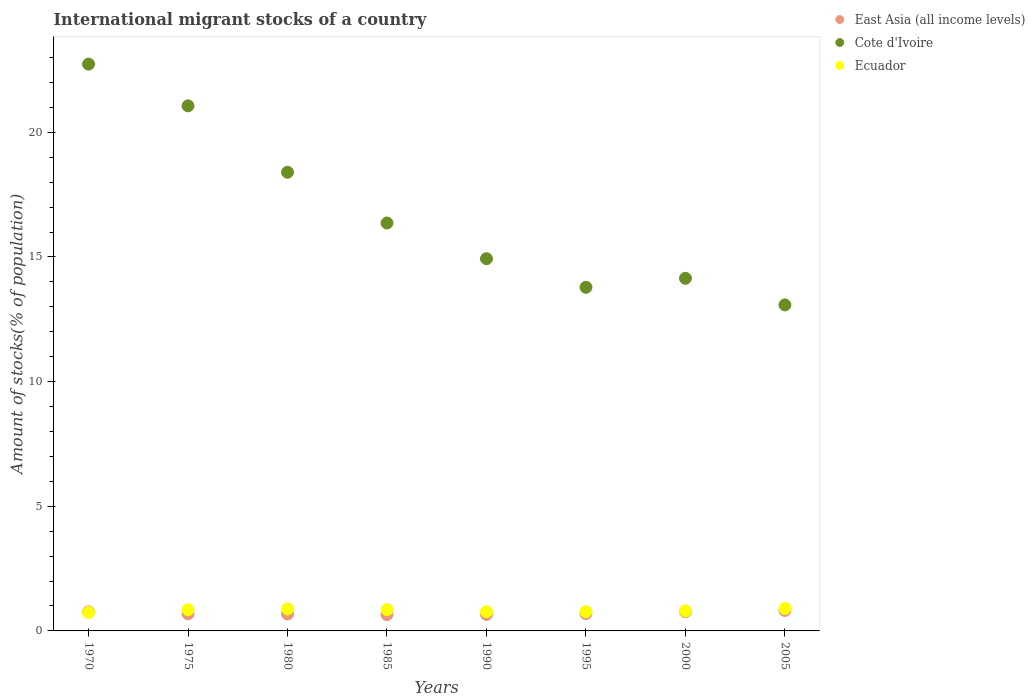How many different coloured dotlines are there?
Offer a terse response. 3. Is the number of dotlines equal to the number of legend labels?
Give a very brief answer. Yes. What is the amount of stocks in in East Asia (all income levels) in 1980?
Provide a short and direct response. 0.68. Across all years, what is the maximum amount of stocks in in Ecuador?
Give a very brief answer. 0.9. Across all years, what is the minimum amount of stocks in in Cote d'Ivoire?
Offer a very short reply. 13.08. In which year was the amount of stocks in in Ecuador minimum?
Provide a succinct answer. 1970. What is the total amount of stocks in in Ecuador in the graph?
Your response must be concise. 6.57. What is the difference between the amount of stocks in in Ecuador in 1970 and that in 1980?
Your answer should be very brief. -0.14. What is the difference between the amount of stocks in in Cote d'Ivoire in 2005 and the amount of stocks in in East Asia (all income levels) in 1980?
Provide a short and direct response. 12.4. What is the average amount of stocks in in East Asia (all income levels) per year?
Your response must be concise. 0.72. In the year 1975, what is the difference between the amount of stocks in in Cote d'Ivoire and amount of stocks in in Ecuador?
Provide a short and direct response. 20.21. What is the ratio of the amount of stocks in in Cote d'Ivoire in 1975 to that in 2000?
Provide a succinct answer. 1.49. Is the amount of stocks in in Cote d'Ivoire in 1985 less than that in 2005?
Your response must be concise. No. Is the difference between the amount of stocks in in Cote d'Ivoire in 1990 and 1995 greater than the difference between the amount of stocks in in Ecuador in 1990 and 1995?
Your answer should be compact. Yes. What is the difference between the highest and the second highest amount of stocks in in Cote d'Ivoire?
Provide a short and direct response. 1.67. What is the difference between the highest and the lowest amount of stocks in in Cote d'Ivoire?
Offer a terse response. 9.66. In how many years, is the amount of stocks in in Cote d'Ivoire greater than the average amount of stocks in in Cote d'Ivoire taken over all years?
Ensure brevity in your answer.  3. Is it the case that in every year, the sum of the amount of stocks in in East Asia (all income levels) and amount of stocks in in Cote d'Ivoire  is greater than the amount of stocks in in Ecuador?
Provide a short and direct response. Yes. Does the amount of stocks in in Cote d'Ivoire monotonically increase over the years?
Give a very brief answer. No. Is the amount of stocks in in Cote d'Ivoire strictly greater than the amount of stocks in in Ecuador over the years?
Your answer should be very brief. Yes. Are the values on the major ticks of Y-axis written in scientific E-notation?
Your answer should be compact. No. Does the graph contain any zero values?
Your answer should be very brief. No. How are the legend labels stacked?
Offer a very short reply. Vertical. What is the title of the graph?
Provide a short and direct response. International migrant stocks of a country. Does "Switzerland" appear as one of the legend labels in the graph?
Make the answer very short. No. What is the label or title of the X-axis?
Ensure brevity in your answer.  Years. What is the label or title of the Y-axis?
Your answer should be compact. Amount of stocks(% of population). What is the Amount of stocks(% of population) of East Asia (all income levels) in 1970?
Provide a short and direct response. 0.76. What is the Amount of stocks(% of population) of Cote d'Ivoire in 1970?
Offer a very short reply. 22.74. What is the Amount of stocks(% of population) of Ecuador in 1970?
Your answer should be very brief. 0.74. What is the Amount of stocks(% of population) in East Asia (all income levels) in 1975?
Give a very brief answer. 0.69. What is the Amount of stocks(% of population) in Cote d'Ivoire in 1975?
Ensure brevity in your answer.  21.06. What is the Amount of stocks(% of population) of Ecuador in 1975?
Ensure brevity in your answer.  0.85. What is the Amount of stocks(% of population) in East Asia (all income levels) in 1980?
Keep it short and to the point. 0.68. What is the Amount of stocks(% of population) in Cote d'Ivoire in 1980?
Your answer should be compact. 18.4. What is the Amount of stocks(% of population) in Ecuador in 1980?
Your answer should be compact. 0.88. What is the Amount of stocks(% of population) in East Asia (all income levels) in 1985?
Give a very brief answer. 0.66. What is the Amount of stocks(% of population) in Cote d'Ivoire in 1985?
Your response must be concise. 16.36. What is the Amount of stocks(% of population) of Ecuador in 1985?
Provide a short and direct response. 0.85. What is the Amount of stocks(% of population) in East Asia (all income levels) in 1990?
Keep it short and to the point. 0.66. What is the Amount of stocks(% of population) in Cote d'Ivoire in 1990?
Provide a short and direct response. 14.93. What is the Amount of stocks(% of population) in Ecuador in 1990?
Offer a very short reply. 0.77. What is the Amount of stocks(% of population) in East Asia (all income levels) in 1995?
Offer a terse response. 0.7. What is the Amount of stocks(% of population) in Cote d'Ivoire in 1995?
Keep it short and to the point. 13.78. What is the Amount of stocks(% of population) in Ecuador in 1995?
Keep it short and to the point. 0.77. What is the Amount of stocks(% of population) in East Asia (all income levels) in 2000?
Give a very brief answer. 0.77. What is the Amount of stocks(% of population) of Cote d'Ivoire in 2000?
Provide a succinct answer. 14.14. What is the Amount of stocks(% of population) in Ecuador in 2000?
Provide a succinct answer. 0.8. What is the Amount of stocks(% of population) in East Asia (all income levels) in 2005?
Your response must be concise. 0.82. What is the Amount of stocks(% of population) in Cote d'Ivoire in 2005?
Offer a very short reply. 13.08. What is the Amount of stocks(% of population) in Ecuador in 2005?
Give a very brief answer. 0.9. Across all years, what is the maximum Amount of stocks(% of population) of East Asia (all income levels)?
Make the answer very short. 0.82. Across all years, what is the maximum Amount of stocks(% of population) in Cote d'Ivoire?
Ensure brevity in your answer.  22.74. Across all years, what is the maximum Amount of stocks(% of population) of Ecuador?
Provide a short and direct response. 0.9. Across all years, what is the minimum Amount of stocks(% of population) in East Asia (all income levels)?
Make the answer very short. 0.66. Across all years, what is the minimum Amount of stocks(% of population) of Cote d'Ivoire?
Your response must be concise. 13.08. Across all years, what is the minimum Amount of stocks(% of population) of Ecuador?
Offer a very short reply. 0.74. What is the total Amount of stocks(% of population) of East Asia (all income levels) in the graph?
Make the answer very short. 5.73. What is the total Amount of stocks(% of population) of Cote d'Ivoire in the graph?
Keep it short and to the point. 134.49. What is the total Amount of stocks(% of population) of Ecuador in the graph?
Your response must be concise. 6.57. What is the difference between the Amount of stocks(% of population) in East Asia (all income levels) in 1970 and that in 1975?
Provide a succinct answer. 0.08. What is the difference between the Amount of stocks(% of population) of Cote d'Ivoire in 1970 and that in 1975?
Give a very brief answer. 1.67. What is the difference between the Amount of stocks(% of population) in Ecuador in 1970 and that in 1975?
Give a very brief answer. -0.11. What is the difference between the Amount of stocks(% of population) of East Asia (all income levels) in 1970 and that in 1980?
Give a very brief answer. 0.09. What is the difference between the Amount of stocks(% of population) of Cote d'Ivoire in 1970 and that in 1980?
Provide a short and direct response. 4.34. What is the difference between the Amount of stocks(% of population) of Ecuador in 1970 and that in 1980?
Ensure brevity in your answer.  -0.14. What is the difference between the Amount of stocks(% of population) of East Asia (all income levels) in 1970 and that in 1985?
Provide a succinct answer. 0.11. What is the difference between the Amount of stocks(% of population) in Cote d'Ivoire in 1970 and that in 1985?
Provide a succinct answer. 6.38. What is the difference between the Amount of stocks(% of population) of Ecuador in 1970 and that in 1985?
Keep it short and to the point. -0.12. What is the difference between the Amount of stocks(% of population) in East Asia (all income levels) in 1970 and that in 1990?
Make the answer very short. 0.1. What is the difference between the Amount of stocks(% of population) in Cote d'Ivoire in 1970 and that in 1990?
Ensure brevity in your answer.  7.81. What is the difference between the Amount of stocks(% of population) of Ecuador in 1970 and that in 1990?
Provide a succinct answer. -0.03. What is the difference between the Amount of stocks(% of population) in East Asia (all income levels) in 1970 and that in 1995?
Make the answer very short. 0.07. What is the difference between the Amount of stocks(% of population) in Cote d'Ivoire in 1970 and that in 1995?
Give a very brief answer. 8.95. What is the difference between the Amount of stocks(% of population) of Ecuador in 1970 and that in 1995?
Your answer should be compact. -0.03. What is the difference between the Amount of stocks(% of population) in East Asia (all income levels) in 1970 and that in 2000?
Offer a terse response. -0. What is the difference between the Amount of stocks(% of population) in Cote d'Ivoire in 1970 and that in 2000?
Give a very brief answer. 8.59. What is the difference between the Amount of stocks(% of population) of Ecuador in 1970 and that in 2000?
Keep it short and to the point. -0.07. What is the difference between the Amount of stocks(% of population) in East Asia (all income levels) in 1970 and that in 2005?
Make the answer very short. -0.06. What is the difference between the Amount of stocks(% of population) of Cote d'Ivoire in 1970 and that in 2005?
Give a very brief answer. 9.66. What is the difference between the Amount of stocks(% of population) of Ecuador in 1970 and that in 2005?
Ensure brevity in your answer.  -0.16. What is the difference between the Amount of stocks(% of population) in East Asia (all income levels) in 1975 and that in 1980?
Offer a very short reply. 0.01. What is the difference between the Amount of stocks(% of population) of Cote d'Ivoire in 1975 and that in 1980?
Offer a very short reply. 2.66. What is the difference between the Amount of stocks(% of population) of Ecuador in 1975 and that in 1980?
Give a very brief answer. -0.03. What is the difference between the Amount of stocks(% of population) in East Asia (all income levels) in 1975 and that in 1985?
Provide a short and direct response. 0.03. What is the difference between the Amount of stocks(% of population) in Cote d'Ivoire in 1975 and that in 1985?
Keep it short and to the point. 4.7. What is the difference between the Amount of stocks(% of population) in Ecuador in 1975 and that in 1985?
Ensure brevity in your answer.  -0. What is the difference between the Amount of stocks(% of population) in East Asia (all income levels) in 1975 and that in 1990?
Your response must be concise. 0.02. What is the difference between the Amount of stocks(% of population) in Cote d'Ivoire in 1975 and that in 1990?
Your answer should be very brief. 6.13. What is the difference between the Amount of stocks(% of population) of Ecuador in 1975 and that in 1990?
Keep it short and to the point. 0.08. What is the difference between the Amount of stocks(% of population) in East Asia (all income levels) in 1975 and that in 1995?
Ensure brevity in your answer.  -0.01. What is the difference between the Amount of stocks(% of population) in Cote d'Ivoire in 1975 and that in 1995?
Your answer should be very brief. 7.28. What is the difference between the Amount of stocks(% of population) of Ecuador in 1975 and that in 1995?
Make the answer very short. 0.08. What is the difference between the Amount of stocks(% of population) in East Asia (all income levels) in 1975 and that in 2000?
Your answer should be very brief. -0.08. What is the difference between the Amount of stocks(% of population) in Cote d'Ivoire in 1975 and that in 2000?
Your response must be concise. 6.92. What is the difference between the Amount of stocks(% of population) in Ecuador in 1975 and that in 2000?
Give a very brief answer. 0.05. What is the difference between the Amount of stocks(% of population) in East Asia (all income levels) in 1975 and that in 2005?
Make the answer very short. -0.14. What is the difference between the Amount of stocks(% of population) in Cote d'Ivoire in 1975 and that in 2005?
Provide a succinct answer. 7.98. What is the difference between the Amount of stocks(% of population) in Ecuador in 1975 and that in 2005?
Keep it short and to the point. -0.05. What is the difference between the Amount of stocks(% of population) in East Asia (all income levels) in 1980 and that in 1985?
Make the answer very short. 0.02. What is the difference between the Amount of stocks(% of population) of Cote d'Ivoire in 1980 and that in 1985?
Your answer should be compact. 2.04. What is the difference between the Amount of stocks(% of population) of Ecuador in 1980 and that in 1985?
Provide a succinct answer. 0.03. What is the difference between the Amount of stocks(% of population) of East Asia (all income levels) in 1980 and that in 1990?
Offer a very short reply. 0.02. What is the difference between the Amount of stocks(% of population) of Cote d'Ivoire in 1980 and that in 1990?
Your answer should be very brief. 3.47. What is the difference between the Amount of stocks(% of population) of Ecuador in 1980 and that in 1990?
Provide a succinct answer. 0.11. What is the difference between the Amount of stocks(% of population) of East Asia (all income levels) in 1980 and that in 1995?
Give a very brief answer. -0.02. What is the difference between the Amount of stocks(% of population) of Cote d'Ivoire in 1980 and that in 1995?
Provide a short and direct response. 4.62. What is the difference between the Amount of stocks(% of population) of Ecuador in 1980 and that in 1995?
Provide a succinct answer. 0.11. What is the difference between the Amount of stocks(% of population) of East Asia (all income levels) in 1980 and that in 2000?
Make the answer very short. -0.09. What is the difference between the Amount of stocks(% of population) of Cote d'Ivoire in 1980 and that in 2000?
Offer a very short reply. 4.25. What is the difference between the Amount of stocks(% of population) in Ecuador in 1980 and that in 2000?
Make the answer very short. 0.08. What is the difference between the Amount of stocks(% of population) in East Asia (all income levels) in 1980 and that in 2005?
Provide a succinct answer. -0.14. What is the difference between the Amount of stocks(% of population) of Cote d'Ivoire in 1980 and that in 2005?
Keep it short and to the point. 5.32. What is the difference between the Amount of stocks(% of population) in Ecuador in 1980 and that in 2005?
Keep it short and to the point. -0.02. What is the difference between the Amount of stocks(% of population) in East Asia (all income levels) in 1985 and that in 1990?
Your response must be concise. -0.01. What is the difference between the Amount of stocks(% of population) of Cote d'Ivoire in 1985 and that in 1990?
Give a very brief answer. 1.43. What is the difference between the Amount of stocks(% of population) of Ecuador in 1985 and that in 1990?
Provide a short and direct response. 0.08. What is the difference between the Amount of stocks(% of population) in East Asia (all income levels) in 1985 and that in 1995?
Your response must be concise. -0.04. What is the difference between the Amount of stocks(% of population) of Cote d'Ivoire in 1985 and that in 1995?
Your answer should be compact. 2.58. What is the difference between the Amount of stocks(% of population) in Ecuador in 1985 and that in 1995?
Your answer should be very brief. 0.08. What is the difference between the Amount of stocks(% of population) in East Asia (all income levels) in 1985 and that in 2000?
Make the answer very short. -0.11. What is the difference between the Amount of stocks(% of population) in Cote d'Ivoire in 1985 and that in 2000?
Provide a succinct answer. 2.22. What is the difference between the Amount of stocks(% of population) of Ecuador in 1985 and that in 2000?
Your answer should be very brief. 0.05. What is the difference between the Amount of stocks(% of population) in East Asia (all income levels) in 1985 and that in 2005?
Ensure brevity in your answer.  -0.17. What is the difference between the Amount of stocks(% of population) in Cote d'Ivoire in 1985 and that in 2005?
Your answer should be compact. 3.28. What is the difference between the Amount of stocks(% of population) in Ecuador in 1985 and that in 2005?
Provide a succinct answer. -0.05. What is the difference between the Amount of stocks(% of population) of East Asia (all income levels) in 1990 and that in 1995?
Provide a succinct answer. -0.04. What is the difference between the Amount of stocks(% of population) of Cote d'Ivoire in 1990 and that in 1995?
Your answer should be very brief. 1.15. What is the difference between the Amount of stocks(% of population) in Ecuador in 1990 and that in 1995?
Your answer should be compact. -0. What is the difference between the Amount of stocks(% of population) of East Asia (all income levels) in 1990 and that in 2000?
Keep it short and to the point. -0.11. What is the difference between the Amount of stocks(% of population) of Cote d'Ivoire in 1990 and that in 2000?
Your response must be concise. 0.79. What is the difference between the Amount of stocks(% of population) of Ecuador in 1990 and that in 2000?
Your answer should be compact. -0.03. What is the difference between the Amount of stocks(% of population) in East Asia (all income levels) in 1990 and that in 2005?
Keep it short and to the point. -0.16. What is the difference between the Amount of stocks(% of population) in Cote d'Ivoire in 1990 and that in 2005?
Offer a very short reply. 1.85. What is the difference between the Amount of stocks(% of population) of Ecuador in 1990 and that in 2005?
Keep it short and to the point. -0.13. What is the difference between the Amount of stocks(% of population) in East Asia (all income levels) in 1995 and that in 2000?
Ensure brevity in your answer.  -0.07. What is the difference between the Amount of stocks(% of population) in Cote d'Ivoire in 1995 and that in 2000?
Provide a short and direct response. -0.36. What is the difference between the Amount of stocks(% of population) of Ecuador in 1995 and that in 2000?
Keep it short and to the point. -0.03. What is the difference between the Amount of stocks(% of population) of East Asia (all income levels) in 1995 and that in 2005?
Offer a terse response. -0.13. What is the difference between the Amount of stocks(% of population) of Cote d'Ivoire in 1995 and that in 2005?
Your answer should be compact. 0.7. What is the difference between the Amount of stocks(% of population) in Ecuador in 1995 and that in 2005?
Make the answer very short. -0.13. What is the difference between the Amount of stocks(% of population) of East Asia (all income levels) in 2000 and that in 2005?
Ensure brevity in your answer.  -0.05. What is the difference between the Amount of stocks(% of population) of Cote d'Ivoire in 2000 and that in 2005?
Your response must be concise. 1.07. What is the difference between the Amount of stocks(% of population) in Ecuador in 2000 and that in 2005?
Your answer should be very brief. -0.1. What is the difference between the Amount of stocks(% of population) in East Asia (all income levels) in 1970 and the Amount of stocks(% of population) in Cote d'Ivoire in 1975?
Offer a very short reply. -20.3. What is the difference between the Amount of stocks(% of population) of East Asia (all income levels) in 1970 and the Amount of stocks(% of population) of Ecuador in 1975?
Give a very brief answer. -0.08. What is the difference between the Amount of stocks(% of population) of Cote d'Ivoire in 1970 and the Amount of stocks(% of population) of Ecuador in 1975?
Your answer should be compact. 21.89. What is the difference between the Amount of stocks(% of population) of East Asia (all income levels) in 1970 and the Amount of stocks(% of population) of Cote d'Ivoire in 1980?
Keep it short and to the point. -17.63. What is the difference between the Amount of stocks(% of population) in East Asia (all income levels) in 1970 and the Amount of stocks(% of population) in Ecuador in 1980?
Provide a short and direct response. -0.12. What is the difference between the Amount of stocks(% of population) of Cote d'Ivoire in 1970 and the Amount of stocks(% of population) of Ecuador in 1980?
Keep it short and to the point. 21.85. What is the difference between the Amount of stocks(% of population) of East Asia (all income levels) in 1970 and the Amount of stocks(% of population) of Cote d'Ivoire in 1985?
Offer a very short reply. -15.6. What is the difference between the Amount of stocks(% of population) in East Asia (all income levels) in 1970 and the Amount of stocks(% of population) in Ecuador in 1985?
Your answer should be compact. -0.09. What is the difference between the Amount of stocks(% of population) in Cote d'Ivoire in 1970 and the Amount of stocks(% of population) in Ecuador in 1985?
Your answer should be compact. 21.88. What is the difference between the Amount of stocks(% of population) of East Asia (all income levels) in 1970 and the Amount of stocks(% of population) of Cote d'Ivoire in 1990?
Your answer should be very brief. -14.17. What is the difference between the Amount of stocks(% of population) in East Asia (all income levels) in 1970 and the Amount of stocks(% of population) in Ecuador in 1990?
Your answer should be very brief. -0.01. What is the difference between the Amount of stocks(% of population) in Cote d'Ivoire in 1970 and the Amount of stocks(% of population) in Ecuador in 1990?
Make the answer very short. 21.97. What is the difference between the Amount of stocks(% of population) of East Asia (all income levels) in 1970 and the Amount of stocks(% of population) of Cote d'Ivoire in 1995?
Ensure brevity in your answer.  -13.02. What is the difference between the Amount of stocks(% of population) in East Asia (all income levels) in 1970 and the Amount of stocks(% of population) in Ecuador in 1995?
Provide a short and direct response. -0.01. What is the difference between the Amount of stocks(% of population) in Cote d'Ivoire in 1970 and the Amount of stocks(% of population) in Ecuador in 1995?
Offer a very short reply. 21.96. What is the difference between the Amount of stocks(% of population) in East Asia (all income levels) in 1970 and the Amount of stocks(% of population) in Cote d'Ivoire in 2000?
Ensure brevity in your answer.  -13.38. What is the difference between the Amount of stocks(% of population) of East Asia (all income levels) in 1970 and the Amount of stocks(% of population) of Ecuador in 2000?
Your answer should be compact. -0.04. What is the difference between the Amount of stocks(% of population) of Cote d'Ivoire in 1970 and the Amount of stocks(% of population) of Ecuador in 2000?
Make the answer very short. 21.93. What is the difference between the Amount of stocks(% of population) in East Asia (all income levels) in 1970 and the Amount of stocks(% of population) in Cote d'Ivoire in 2005?
Provide a succinct answer. -12.31. What is the difference between the Amount of stocks(% of population) of East Asia (all income levels) in 1970 and the Amount of stocks(% of population) of Ecuador in 2005?
Your answer should be very brief. -0.14. What is the difference between the Amount of stocks(% of population) in Cote d'Ivoire in 1970 and the Amount of stocks(% of population) in Ecuador in 2005?
Your response must be concise. 21.84. What is the difference between the Amount of stocks(% of population) in East Asia (all income levels) in 1975 and the Amount of stocks(% of population) in Cote d'Ivoire in 1980?
Your answer should be very brief. -17.71. What is the difference between the Amount of stocks(% of population) of East Asia (all income levels) in 1975 and the Amount of stocks(% of population) of Ecuador in 1980?
Provide a succinct answer. -0.2. What is the difference between the Amount of stocks(% of population) of Cote d'Ivoire in 1975 and the Amount of stocks(% of population) of Ecuador in 1980?
Give a very brief answer. 20.18. What is the difference between the Amount of stocks(% of population) in East Asia (all income levels) in 1975 and the Amount of stocks(% of population) in Cote d'Ivoire in 1985?
Your answer should be compact. -15.68. What is the difference between the Amount of stocks(% of population) of East Asia (all income levels) in 1975 and the Amount of stocks(% of population) of Ecuador in 1985?
Provide a short and direct response. -0.17. What is the difference between the Amount of stocks(% of population) of Cote d'Ivoire in 1975 and the Amount of stocks(% of population) of Ecuador in 1985?
Ensure brevity in your answer.  20.21. What is the difference between the Amount of stocks(% of population) in East Asia (all income levels) in 1975 and the Amount of stocks(% of population) in Cote d'Ivoire in 1990?
Give a very brief answer. -14.25. What is the difference between the Amount of stocks(% of population) in East Asia (all income levels) in 1975 and the Amount of stocks(% of population) in Ecuador in 1990?
Offer a very short reply. -0.08. What is the difference between the Amount of stocks(% of population) of Cote d'Ivoire in 1975 and the Amount of stocks(% of population) of Ecuador in 1990?
Provide a short and direct response. 20.29. What is the difference between the Amount of stocks(% of population) in East Asia (all income levels) in 1975 and the Amount of stocks(% of population) in Cote d'Ivoire in 1995?
Give a very brief answer. -13.1. What is the difference between the Amount of stocks(% of population) in East Asia (all income levels) in 1975 and the Amount of stocks(% of population) in Ecuador in 1995?
Offer a very short reply. -0.09. What is the difference between the Amount of stocks(% of population) in Cote d'Ivoire in 1975 and the Amount of stocks(% of population) in Ecuador in 1995?
Provide a short and direct response. 20.29. What is the difference between the Amount of stocks(% of population) in East Asia (all income levels) in 1975 and the Amount of stocks(% of population) in Cote d'Ivoire in 2000?
Your answer should be compact. -13.46. What is the difference between the Amount of stocks(% of population) in East Asia (all income levels) in 1975 and the Amount of stocks(% of population) in Ecuador in 2000?
Your response must be concise. -0.12. What is the difference between the Amount of stocks(% of population) of Cote d'Ivoire in 1975 and the Amount of stocks(% of population) of Ecuador in 2000?
Your answer should be compact. 20.26. What is the difference between the Amount of stocks(% of population) in East Asia (all income levels) in 1975 and the Amount of stocks(% of population) in Cote d'Ivoire in 2005?
Your response must be concise. -12.39. What is the difference between the Amount of stocks(% of population) in East Asia (all income levels) in 1975 and the Amount of stocks(% of population) in Ecuador in 2005?
Provide a succinct answer. -0.21. What is the difference between the Amount of stocks(% of population) of Cote d'Ivoire in 1975 and the Amount of stocks(% of population) of Ecuador in 2005?
Offer a very short reply. 20.16. What is the difference between the Amount of stocks(% of population) in East Asia (all income levels) in 1980 and the Amount of stocks(% of population) in Cote d'Ivoire in 1985?
Make the answer very short. -15.68. What is the difference between the Amount of stocks(% of population) of East Asia (all income levels) in 1980 and the Amount of stocks(% of population) of Ecuador in 1985?
Your answer should be compact. -0.17. What is the difference between the Amount of stocks(% of population) of Cote d'Ivoire in 1980 and the Amount of stocks(% of population) of Ecuador in 1985?
Provide a short and direct response. 17.54. What is the difference between the Amount of stocks(% of population) of East Asia (all income levels) in 1980 and the Amount of stocks(% of population) of Cote d'Ivoire in 1990?
Provide a succinct answer. -14.25. What is the difference between the Amount of stocks(% of population) in East Asia (all income levels) in 1980 and the Amount of stocks(% of population) in Ecuador in 1990?
Make the answer very short. -0.09. What is the difference between the Amount of stocks(% of population) of Cote d'Ivoire in 1980 and the Amount of stocks(% of population) of Ecuador in 1990?
Your answer should be very brief. 17.63. What is the difference between the Amount of stocks(% of population) of East Asia (all income levels) in 1980 and the Amount of stocks(% of population) of Cote d'Ivoire in 1995?
Make the answer very short. -13.1. What is the difference between the Amount of stocks(% of population) in East Asia (all income levels) in 1980 and the Amount of stocks(% of population) in Ecuador in 1995?
Your response must be concise. -0.09. What is the difference between the Amount of stocks(% of population) of Cote d'Ivoire in 1980 and the Amount of stocks(% of population) of Ecuador in 1995?
Offer a very short reply. 17.63. What is the difference between the Amount of stocks(% of population) in East Asia (all income levels) in 1980 and the Amount of stocks(% of population) in Cote d'Ivoire in 2000?
Ensure brevity in your answer.  -13.47. What is the difference between the Amount of stocks(% of population) of East Asia (all income levels) in 1980 and the Amount of stocks(% of population) of Ecuador in 2000?
Provide a short and direct response. -0.12. What is the difference between the Amount of stocks(% of population) in Cote d'Ivoire in 1980 and the Amount of stocks(% of population) in Ecuador in 2000?
Provide a succinct answer. 17.6. What is the difference between the Amount of stocks(% of population) of East Asia (all income levels) in 1980 and the Amount of stocks(% of population) of Cote d'Ivoire in 2005?
Ensure brevity in your answer.  -12.4. What is the difference between the Amount of stocks(% of population) in East Asia (all income levels) in 1980 and the Amount of stocks(% of population) in Ecuador in 2005?
Give a very brief answer. -0.22. What is the difference between the Amount of stocks(% of population) of Cote d'Ivoire in 1980 and the Amount of stocks(% of population) of Ecuador in 2005?
Ensure brevity in your answer.  17.5. What is the difference between the Amount of stocks(% of population) of East Asia (all income levels) in 1985 and the Amount of stocks(% of population) of Cote d'Ivoire in 1990?
Keep it short and to the point. -14.28. What is the difference between the Amount of stocks(% of population) in East Asia (all income levels) in 1985 and the Amount of stocks(% of population) in Ecuador in 1990?
Offer a terse response. -0.11. What is the difference between the Amount of stocks(% of population) in Cote d'Ivoire in 1985 and the Amount of stocks(% of population) in Ecuador in 1990?
Your answer should be very brief. 15.59. What is the difference between the Amount of stocks(% of population) of East Asia (all income levels) in 1985 and the Amount of stocks(% of population) of Cote d'Ivoire in 1995?
Offer a very short reply. -13.13. What is the difference between the Amount of stocks(% of population) of East Asia (all income levels) in 1985 and the Amount of stocks(% of population) of Ecuador in 1995?
Ensure brevity in your answer.  -0.12. What is the difference between the Amount of stocks(% of population) of Cote d'Ivoire in 1985 and the Amount of stocks(% of population) of Ecuador in 1995?
Ensure brevity in your answer.  15.59. What is the difference between the Amount of stocks(% of population) of East Asia (all income levels) in 1985 and the Amount of stocks(% of population) of Cote d'Ivoire in 2000?
Keep it short and to the point. -13.49. What is the difference between the Amount of stocks(% of population) of East Asia (all income levels) in 1985 and the Amount of stocks(% of population) of Ecuador in 2000?
Give a very brief answer. -0.15. What is the difference between the Amount of stocks(% of population) of Cote d'Ivoire in 1985 and the Amount of stocks(% of population) of Ecuador in 2000?
Keep it short and to the point. 15.56. What is the difference between the Amount of stocks(% of population) of East Asia (all income levels) in 1985 and the Amount of stocks(% of population) of Cote d'Ivoire in 2005?
Offer a very short reply. -12.42. What is the difference between the Amount of stocks(% of population) in East Asia (all income levels) in 1985 and the Amount of stocks(% of population) in Ecuador in 2005?
Provide a succinct answer. -0.24. What is the difference between the Amount of stocks(% of population) in Cote d'Ivoire in 1985 and the Amount of stocks(% of population) in Ecuador in 2005?
Offer a terse response. 15.46. What is the difference between the Amount of stocks(% of population) in East Asia (all income levels) in 1990 and the Amount of stocks(% of population) in Cote d'Ivoire in 1995?
Make the answer very short. -13.12. What is the difference between the Amount of stocks(% of population) in East Asia (all income levels) in 1990 and the Amount of stocks(% of population) in Ecuador in 1995?
Your answer should be compact. -0.11. What is the difference between the Amount of stocks(% of population) of Cote d'Ivoire in 1990 and the Amount of stocks(% of population) of Ecuador in 1995?
Provide a short and direct response. 14.16. What is the difference between the Amount of stocks(% of population) in East Asia (all income levels) in 1990 and the Amount of stocks(% of population) in Cote d'Ivoire in 2000?
Offer a very short reply. -13.48. What is the difference between the Amount of stocks(% of population) of East Asia (all income levels) in 1990 and the Amount of stocks(% of population) of Ecuador in 2000?
Your answer should be compact. -0.14. What is the difference between the Amount of stocks(% of population) of Cote d'Ivoire in 1990 and the Amount of stocks(% of population) of Ecuador in 2000?
Your answer should be very brief. 14.13. What is the difference between the Amount of stocks(% of population) in East Asia (all income levels) in 1990 and the Amount of stocks(% of population) in Cote d'Ivoire in 2005?
Provide a succinct answer. -12.42. What is the difference between the Amount of stocks(% of population) of East Asia (all income levels) in 1990 and the Amount of stocks(% of population) of Ecuador in 2005?
Your answer should be very brief. -0.24. What is the difference between the Amount of stocks(% of population) of Cote d'Ivoire in 1990 and the Amount of stocks(% of population) of Ecuador in 2005?
Provide a short and direct response. 14.03. What is the difference between the Amount of stocks(% of population) of East Asia (all income levels) in 1995 and the Amount of stocks(% of population) of Cote d'Ivoire in 2000?
Your response must be concise. -13.45. What is the difference between the Amount of stocks(% of population) in East Asia (all income levels) in 1995 and the Amount of stocks(% of population) in Ecuador in 2000?
Give a very brief answer. -0.11. What is the difference between the Amount of stocks(% of population) in Cote d'Ivoire in 1995 and the Amount of stocks(% of population) in Ecuador in 2000?
Offer a very short reply. 12.98. What is the difference between the Amount of stocks(% of population) in East Asia (all income levels) in 1995 and the Amount of stocks(% of population) in Cote d'Ivoire in 2005?
Offer a very short reply. -12.38. What is the difference between the Amount of stocks(% of population) in East Asia (all income levels) in 1995 and the Amount of stocks(% of population) in Ecuador in 2005?
Your response must be concise. -0.2. What is the difference between the Amount of stocks(% of population) in Cote d'Ivoire in 1995 and the Amount of stocks(% of population) in Ecuador in 2005?
Make the answer very short. 12.88. What is the difference between the Amount of stocks(% of population) in East Asia (all income levels) in 2000 and the Amount of stocks(% of population) in Cote d'Ivoire in 2005?
Your answer should be compact. -12.31. What is the difference between the Amount of stocks(% of population) in East Asia (all income levels) in 2000 and the Amount of stocks(% of population) in Ecuador in 2005?
Give a very brief answer. -0.13. What is the difference between the Amount of stocks(% of population) in Cote d'Ivoire in 2000 and the Amount of stocks(% of population) in Ecuador in 2005?
Provide a short and direct response. 13.24. What is the average Amount of stocks(% of population) in East Asia (all income levels) per year?
Ensure brevity in your answer.  0.72. What is the average Amount of stocks(% of population) of Cote d'Ivoire per year?
Give a very brief answer. 16.81. What is the average Amount of stocks(% of population) in Ecuador per year?
Provide a short and direct response. 0.82. In the year 1970, what is the difference between the Amount of stocks(% of population) of East Asia (all income levels) and Amount of stocks(% of population) of Cote d'Ivoire?
Offer a terse response. -21.97. In the year 1970, what is the difference between the Amount of stocks(% of population) in East Asia (all income levels) and Amount of stocks(% of population) in Ecuador?
Give a very brief answer. 0.03. In the year 1970, what is the difference between the Amount of stocks(% of population) in Cote d'Ivoire and Amount of stocks(% of population) in Ecuador?
Provide a short and direct response. 22. In the year 1975, what is the difference between the Amount of stocks(% of population) of East Asia (all income levels) and Amount of stocks(% of population) of Cote d'Ivoire?
Ensure brevity in your answer.  -20.38. In the year 1975, what is the difference between the Amount of stocks(% of population) of East Asia (all income levels) and Amount of stocks(% of population) of Ecuador?
Keep it short and to the point. -0.16. In the year 1975, what is the difference between the Amount of stocks(% of population) in Cote d'Ivoire and Amount of stocks(% of population) in Ecuador?
Provide a short and direct response. 20.21. In the year 1980, what is the difference between the Amount of stocks(% of population) of East Asia (all income levels) and Amount of stocks(% of population) of Cote d'Ivoire?
Provide a succinct answer. -17.72. In the year 1980, what is the difference between the Amount of stocks(% of population) in East Asia (all income levels) and Amount of stocks(% of population) in Ecuador?
Keep it short and to the point. -0.2. In the year 1980, what is the difference between the Amount of stocks(% of population) of Cote d'Ivoire and Amount of stocks(% of population) of Ecuador?
Your response must be concise. 17.52. In the year 1985, what is the difference between the Amount of stocks(% of population) of East Asia (all income levels) and Amount of stocks(% of population) of Cote d'Ivoire?
Provide a short and direct response. -15.71. In the year 1985, what is the difference between the Amount of stocks(% of population) of East Asia (all income levels) and Amount of stocks(% of population) of Ecuador?
Offer a terse response. -0.2. In the year 1985, what is the difference between the Amount of stocks(% of population) in Cote d'Ivoire and Amount of stocks(% of population) in Ecuador?
Offer a terse response. 15.51. In the year 1990, what is the difference between the Amount of stocks(% of population) of East Asia (all income levels) and Amount of stocks(% of population) of Cote d'Ivoire?
Keep it short and to the point. -14.27. In the year 1990, what is the difference between the Amount of stocks(% of population) in East Asia (all income levels) and Amount of stocks(% of population) in Ecuador?
Ensure brevity in your answer.  -0.11. In the year 1990, what is the difference between the Amount of stocks(% of population) in Cote d'Ivoire and Amount of stocks(% of population) in Ecuador?
Make the answer very short. 14.16. In the year 1995, what is the difference between the Amount of stocks(% of population) in East Asia (all income levels) and Amount of stocks(% of population) in Cote d'Ivoire?
Provide a short and direct response. -13.09. In the year 1995, what is the difference between the Amount of stocks(% of population) of East Asia (all income levels) and Amount of stocks(% of population) of Ecuador?
Your answer should be very brief. -0.08. In the year 1995, what is the difference between the Amount of stocks(% of population) in Cote d'Ivoire and Amount of stocks(% of population) in Ecuador?
Offer a very short reply. 13.01. In the year 2000, what is the difference between the Amount of stocks(% of population) of East Asia (all income levels) and Amount of stocks(% of population) of Cote d'Ivoire?
Give a very brief answer. -13.38. In the year 2000, what is the difference between the Amount of stocks(% of population) in East Asia (all income levels) and Amount of stocks(% of population) in Ecuador?
Make the answer very short. -0.03. In the year 2000, what is the difference between the Amount of stocks(% of population) of Cote d'Ivoire and Amount of stocks(% of population) of Ecuador?
Your answer should be very brief. 13.34. In the year 2005, what is the difference between the Amount of stocks(% of population) in East Asia (all income levels) and Amount of stocks(% of population) in Cote d'Ivoire?
Keep it short and to the point. -12.26. In the year 2005, what is the difference between the Amount of stocks(% of population) of East Asia (all income levels) and Amount of stocks(% of population) of Ecuador?
Provide a short and direct response. -0.08. In the year 2005, what is the difference between the Amount of stocks(% of population) of Cote d'Ivoire and Amount of stocks(% of population) of Ecuador?
Your response must be concise. 12.18. What is the ratio of the Amount of stocks(% of population) in East Asia (all income levels) in 1970 to that in 1975?
Your response must be concise. 1.12. What is the ratio of the Amount of stocks(% of population) in Cote d'Ivoire in 1970 to that in 1975?
Make the answer very short. 1.08. What is the ratio of the Amount of stocks(% of population) in Ecuador in 1970 to that in 1975?
Keep it short and to the point. 0.87. What is the ratio of the Amount of stocks(% of population) of East Asia (all income levels) in 1970 to that in 1980?
Give a very brief answer. 1.13. What is the ratio of the Amount of stocks(% of population) of Cote d'Ivoire in 1970 to that in 1980?
Give a very brief answer. 1.24. What is the ratio of the Amount of stocks(% of population) in Ecuador in 1970 to that in 1980?
Your response must be concise. 0.84. What is the ratio of the Amount of stocks(% of population) in East Asia (all income levels) in 1970 to that in 1985?
Ensure brevity in your answer.  1.17. What is the ratio of the Amount of stocks(% of population) in Cote d'Ivoire in 1970 to that in 1985?
Offer a terse response. 1.39. What is the ratio of the Amount of stocks(% of population) in Ecuador in 1970 to that in 1985?
Give a very brief answer. 0.86. What is the ratio of the Amount of stocks(% of population) of East Asia (all income levels) in 1970 to that in 1990?
Offer a terse response. 1.16. What is the ratio of the Amount of stocks(% of population) in Cote d'Ivoire in 1970 to that in 1990?
Offer a terse response. 1.52. What is the ratio of the Amount of stocks(% of population) of Ecuador in 1970 to that in 1990?
Offer a very short reply. 0.96. What is the ratio of the Amount of stocks(% of population) in East Asia (all income levels) in 1970 to that in 1995?
Offer a very short reply. 1.1. What is the ratio of the Amount of stocks(% of population) in Cote d'Ivoire in 1970 to that in 1995?
Make the answer very short. 1.65. What is the ratio of the Amount of stocks(% of population) of Ecuador in 1970 to that in 1995?
Offer a terse response. 0.96. What is the ratio of the Amount of stocks(% of population) in Cote d'Ivoire in 1970 to that in 2000?
Provide a succinct answer. 1.61. What is the ratio of the Amount of stocks(% of population) in Ecuador in 1970 to that in 2000?
Provide a succinct answer. 0.92. What is the ratio of the Amount of stocks(% of population) in East Asia (all income levels) in 1970 to that in 2005?
Offer a terse response. 0.93. What is the ratio of the Amount of stocks(% of population) of Cote d'Ivoire in 1970 to that in 2005?
Your response must be concise. 1.74. What is the ratio of the Amount of stocks(% of population) of Ecuador in 1970 to that in 2005?
Ensure brevity in your answer.  0.82. What is the ratio of the Amount of stocks(% of population) in East Asia (all income levels) in 1975 to that in 1980?
Offer a very short reply. 1.01. What is the ratio of the Amount of stocks(% of population) of Cote d'Ivoire in 1975 to that in 1980?
Offer a terse response. 1.14. What is the ratio of the Amount of stocks(% of population) of Ecuador in 1975 to that in 1980?
Offer a terse response. 0.96. What is the ratio of the Amount of stocks(% of population) in East Asia (all income levels) in 1975 to that in 1985?
Your answer should be compact. 1.05. What is the ratio of the Amount of stocks(% of population) of Cote d'Ivoire in 1975 to that in 1985?
Your answer should be compact. 1.29. What is the ratio of the Amount of stocks(% of population) in East Asia (all income levels) in 1975 to that in 1990?
Your response must be concise. 1.04. What is the ratio of the Amount of stocks(% of population) in Cote d'Ivoire in 1975 to that in 1990?
Ensure brevity in your answer.  1.41. What is the ratio of the Amount of stocks(% of population) of Ecuador in 1975 to that in 1990?
Offer a very short reply. 1.1. What is the ratio of the Amount of stocks(% of population) in East Asia (all income levels) in 1975 to that in 1995?
Provide a short and direct response. 0.98. What is the ratio of the Amount of stocks(% of population) of Cote d'Ivoire in 1975 to that in 1995?
Your answer should be very brief. 1.53. What is the ratio of the Amount of stocks(% of population) of Ecuador in 1975 to that in 1995?
Your answer should be compact. 1.1. What is the ratio of the Amount of stocks(% of population) in East Asia (all income levels) in 1975 to that in 2000?
Your answer should be very brief. 0.89. What is the ratio of the Amount of stocks(% of population) of Cote d'Ivoire in 1975 to that in 2000?
Your response must be concise. 1.49. What is the ratio of the Amount of stocks(% of population) of Ecuador in 1975 to that in 2000?
Give a very brief answer. 1.06. What is the ratio of the Amount of stocks(% of population) in East Asia (all income levels) in 1975 to that in 2005?
Ensure brevity in your answer.  0.83. What is the ratio of the Amount of stocks(% of population) of Cote d'Ivoire in 1975 to that in 2005?
Keep it short and to the point. 1.61. What is the ratio of the Amount of stocks(% of population) in Ecuador in 1975 to that in 2005?
Give a very brief answer. 0.94. What is the ratio of the Amount of stocks(% of population) in East Asia (all income levels) in 1980 to that in 1985?
Ensure brevity in your answer.  1.04. What is the ratio of the Amount of stocks(% of population) of Cote d'Ivoire in 1980 to that in 1985?
Provide a short and direct response. 1.12. What is the ratio of the Amount of stocks(% of population) of Ecuador in 1980 to that in 1985?
Offer a terse response. 1.03. What is the ratio of the Amount of stocks(% of population) in East Asia (all income levels) in 1980 to that in 1990?
Keep it short and to the point. 1.03. What is the ratio of the Amount of stocks(% of population) of Cote d'Ivoire in 1980 to that in 1990?
Your answer should be very brief. 1.23. What is the ratio of the Amount of stocks(% of population) of Ecuador in 1980 to that in 1990?
Ensure brevity in your answer.  1.15. What is the ratio of the Amount of stocks(% of population) of East Asia (all income levels) in 1980 to that in 1995?
Your answer should be compact. 0.98. What is the ratio of the Amount of stocks(% of population) of Cote d'Ivoire in 1980 to that in 1995?
Provide a short and direct response. 1.33. What is the ratio of the Amount of stocks(% of population) of Ecuador in 1980 to that in 1995?
Offer a terse response. 1.14. What is the ratio of the Amount of stocks(% of population) of East Asia (all income levels) in 1980 to that in 2000?
Your answer should be very brief. 0.88. What is the ratio of the Amount of stocks(% of population) in Cote d'Ivoire in 1980 to that in 2000?
Offer a terse response. 1.3. What is the ratio of the Amount of stocks(% of population) of Ecuador in 1980 to that in 2000?
Keep it short and to the point. 1.1. What is the ratio of the Amount of stocks(% of population) of East Asia (all income levels) in 1980 to that in 2005?
Provide a succinct answer. 0.83. What is the ratio of the Amount of stocks(% of population) in Cote d'Ivoire in 1980 to that in 2005?
Make the answer very short. 1.41. What is the ratio of the Amount of stocks(% of population) of Ecuador in 1980 to that in 2005?
Provide a succinct answer. 0.98. What is the ratio of the Amount of stocks(% of population) in East Asia (all income levels) in 1985 to that in 1990?
Give a very brief answer. 0.99. What is the ratio of the Amount of stocks(% of population) in Cote d'Ivoire in 1985 to that in 1990?
Offer a very short reply. 1.1. What is the ratio of the Amount of stocks(% of population) in Ecuador in 1985 to that in 1990?
Ensure brevity in your answer.  1.11. What is the ratio of the Amount of stocks(% of population) of East Asia (all income levels) in 1985 to that in 1995?
Make the answer very short. 0.94. What is the ratio of the Amount of stocks(% of population) in Cote d'Ivoire in 1985 to that in 1995?
Make the answer very short. 1.19. What is the ratio of the Amount of stocks(% of population) in Ecuador in 1985 to that in 1995?
Your answer should be compact. 1.1. What is the ratio of the Amount of stocks(% of population) of East Asia (all income levels) in 1985 to that in 2000?
Offer a terse response. 0.85. What is the ratio of the Amount of stocks(% of population) in Cote d'Ivoire in 1985 to that in 2000?
Provide a succinct answer. 1.16. What is the ratio of the Amount of stocks(% of population) in Ecuador in 1985 to that in 2000?
Give a very brief answer. 1.06. What is the ratio of the Amount of stocks(% of population) of East Asia (all income levels) in 1985 to that in 2005?
Ensure brevity in your answer.  0.8. What is the ratio of the Amount of stocks(% of population) of Cote d'Ivoire in 1985 to that in 2005?
Offer a very short reply. 1.25. What is the ratio of the Amount of stocks(% of population) of Ecuador in 1985 to that in 2005?
Make the answer very short. 0.95. What is the ratio of the Amount of stocks(% of population) in East Asia (all income levels) in 1990 to that in 1995?
Provide a short and direct response. 0.95. What is the ratio of the Amount of stocks(% of population) in East Asia (all income levels) in 1990 to that in 2000?
Offer a terse response. 0.86. What is the ratio of the Amount of stocks(% of population) in Cote d'Ivoire in 1990 to that in 2000?
Provide a short and direct response. 1.06. What is the ratio of the Amount of stocks(% of population) of Ecuador in 1990 to that in 2000?
Your response must be concise. 0.96. What is the ratio of the Amount of stocks(% of population) in East Asia (all income levels) in 1990 to that in 2005?
Give a very brief answer. 0.8. What is the ratio of the Amount of stocks(% of population) of Cote d'Ivoire in 1990 to that in 2005?
Give a very brief answer. 1.14. What is the ratio of the Amount of stocks(% of population) in Ecuador in 1990 to that in 2005?
Provide a succinct answer. 0.86. What is the ratio of the Amount of stocks(% of population) of East Asia (all income levels) in 1995 to that in 2000?
Keep it short and to the point. 0.91. What is the ratio of the Amount of stocks(% of population) in Cote d'Ivoire in 1995 to that in 2000?
Offer a very short reply. 0.97. What is the ratio of the Amount of stocks(% of population) in Ecuador in 1995 to that in 2000?
Provide a succinct answer. 0.96. What is the ratio of the Amount of stocks(% of population) of East Asia (all income levels) in 1995 to that in 2005?
Your answer should be compact. 0.85. What is the ratio of the Amount of stocks(% of population) of Cote d'Ivoire in 1995 to that in 2005?
Your answer should be very brief. 1.05. What is the ratio of the Amount of stocks(% of population) of Ecuador in 1995 to that in 2005?
Your answer should be very brief. 0.86. What is the ratio of the Amount of stocks(% of population) in East Asia (all income levels) in 2000 to that in 2005?
Keep it short and to the point. 0.94. What is the ratio of the Amount of stocks(% of population) of Cote d'Ivoire in 2000 to that in 2005?
Ensure brevity in your answer.  1.08. What is the ratio of the Amount of stocks(% of population) of Ecuador in 2000 to that in 2005?
Make the answer very short. 0.89. What is the difference between the highest and the second highest Amount of stocks(% of population) of East Asia (all income levels)?
Your answer should be compact. 0.05. What is the difference between the highest and the second highest Amount of stocks(% of population) of Cote d'Ivoire?
Offer a terse response. 1.67. What is the difference between the highest and the second highest Amount of stocks(% of population) in Ecuador?
Provide a succinct answer. 0.02. What is the difference between the highest and the lowest Amount of stocks(% of population) of East Asia (all income levels)?
Provide a succinct answer. 0.17. What is the difference between the highest and the lowest Amount of stocks(% of population) of Cote d'Ivoire?
Offer a very short reply. 9.66. What is the difference between the highest and the lowest Amount of stocks(% of population) of Ecuador?
Offer a terse response. 0.16. 